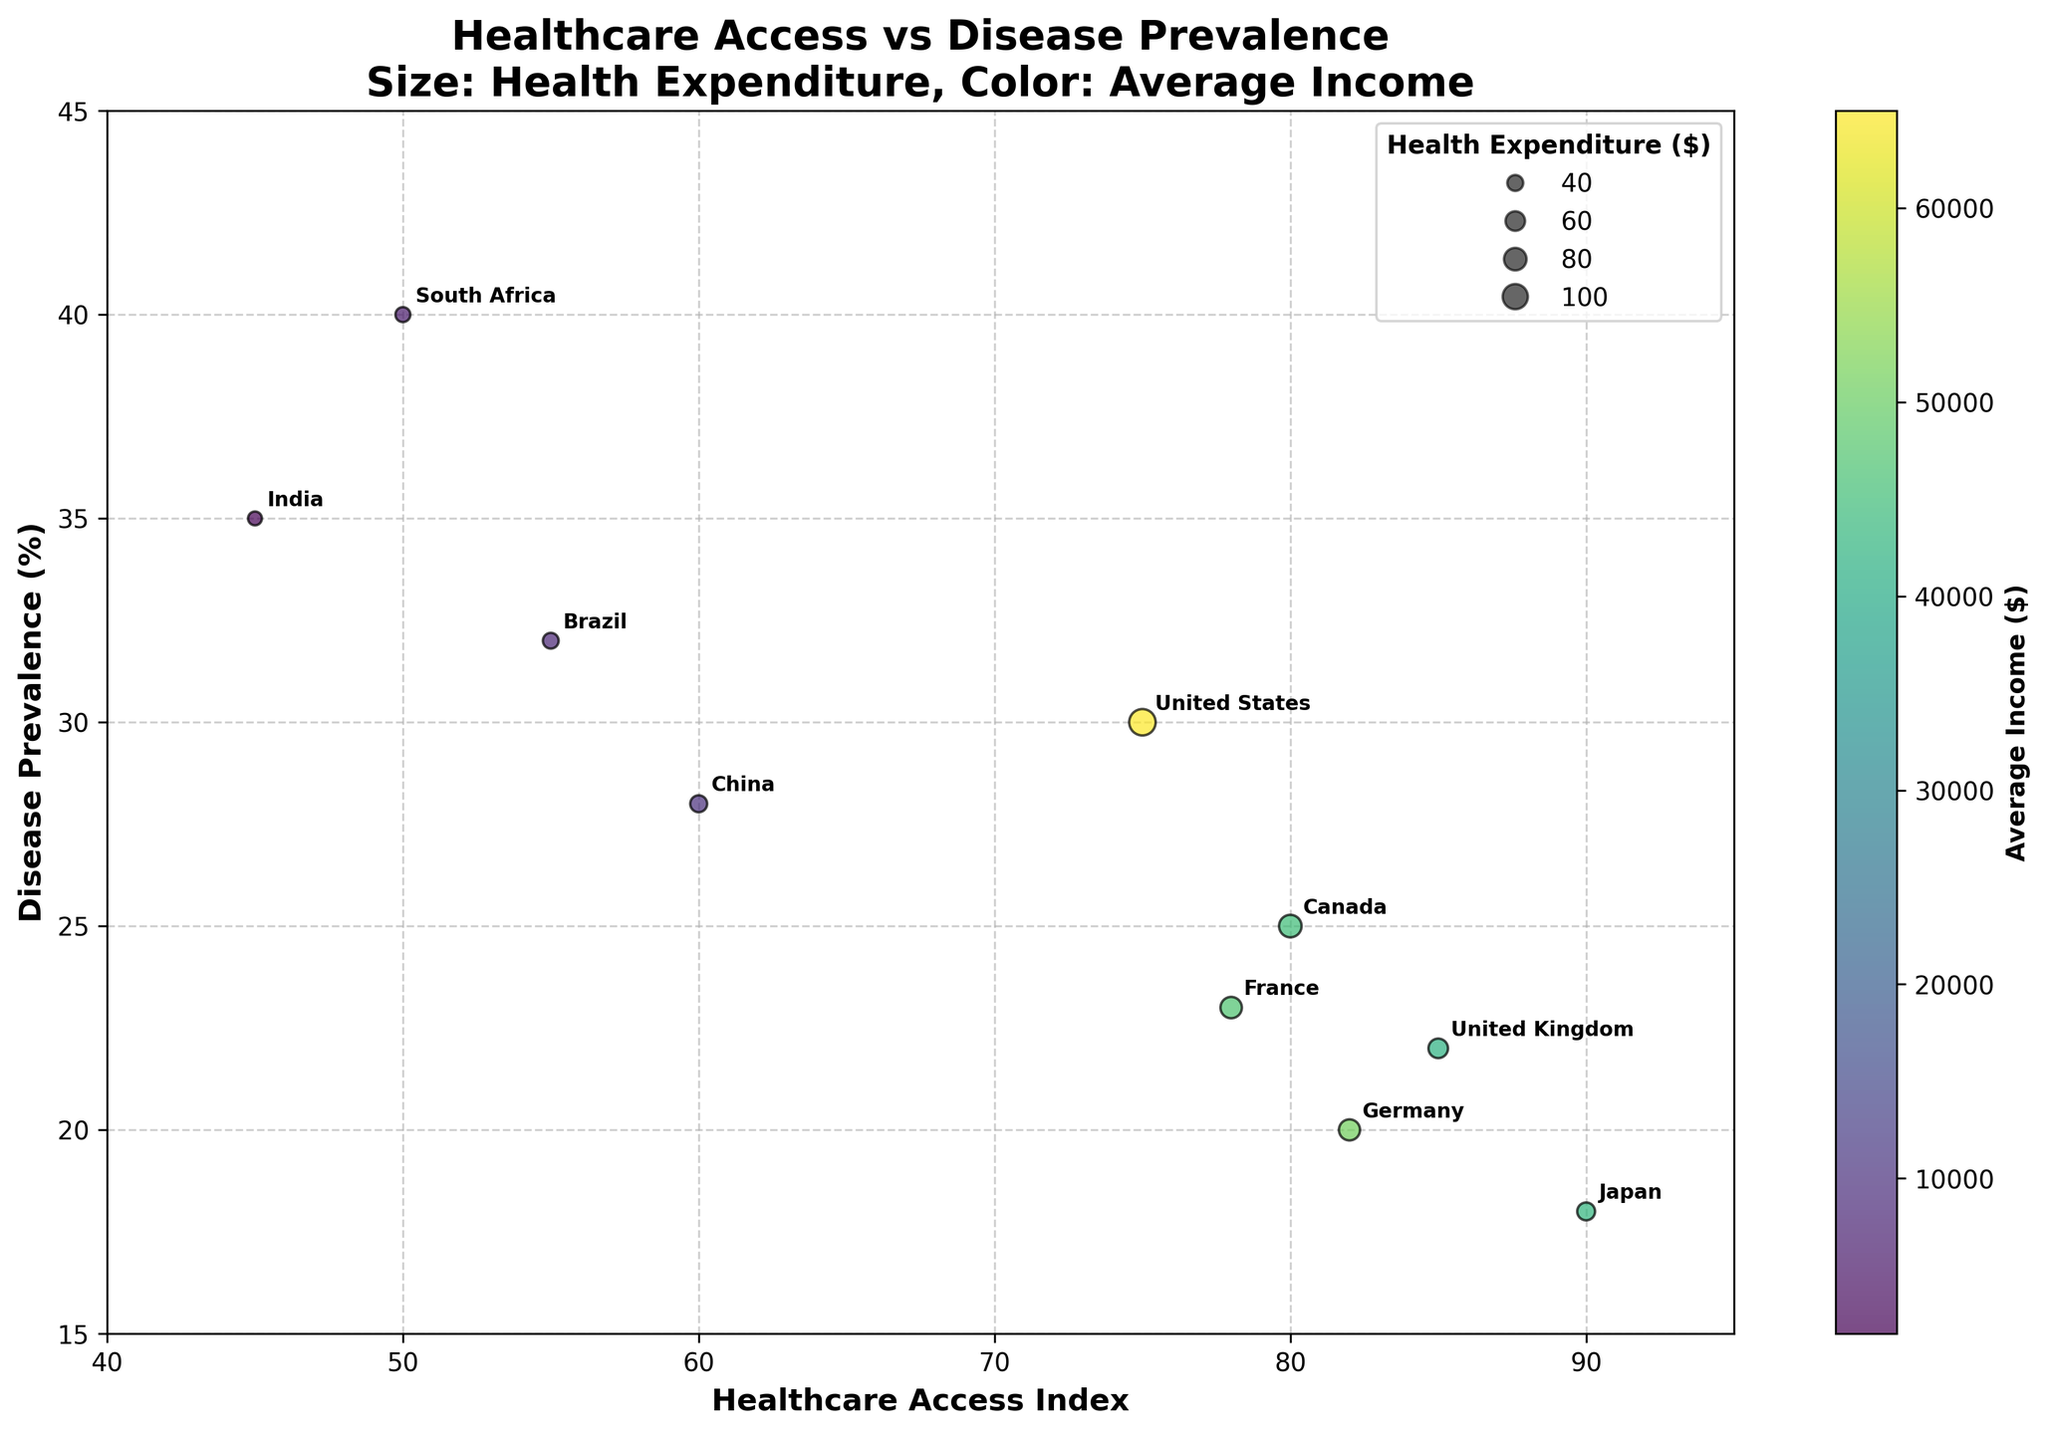what is the title of the figure? The title of the figure is displayed prominently at the top of the image, summarizing the visual content.
Answer: Healthcare Access vs Disease Prevalence How many countries are highlighted in the plot? By counting the annotated labels for each country in the scatter plot, we can see that there are 10 countries mentioned.
Answer: 10 Which country has the highest Disease Prevalence? From examining the scatter plot, South Africa is positioned the highest on the y-axis, indicating it has the highest Disease Prevalence.
Answer: South Africa Which country has the lowest Average Income? Looking at the color gradient of the bubbles, darker colors represent lower incomes. The darkest bubble is annotated with "India".
Answer: India What is the Health Expenditure of the United States? By observing the size of the bubbles, we can see that the United States has the largest bubble, corresponding to the highest Health Expenditure in the plot.
Answer: 11000 What is the Healthcare Access Index for Canada and how does it compare to Germany? By locating Canada and Germany on the x-axis, we see that Canada has a Healthcare Access Index of 80, which is less than Germany's index of 82.
Answer: Canada: 80, Germany: 82 How does the Disease Prevalence of China compare to that of France? China's bubble is positioned higher on the y-axis with a Disease Prevalence of 28%, whereas France has a Disease Prevalence of 23%.
Answer: China: 28%, France: 23% What’s the average amount of Health Expenditure across all the countries? Summing the Health Expenditure values and dividing by the number of countries, (11000+8000+6000+7000+7200+5000+3000+4500+3900+3500)/10, we calculate the average.
Answer: 5920 Which countries have a Healthcare Access Index greater than 80? By observing the x-axis, the countries with a Healthcare Access Index above 80 are Canada (80), Germany (82), United Kingdom (85), and Japan (90).
Answer: Canada, Germany, United Kingdom, Japan What is the relationship between Health Expenditure and Disease Prevalence? By analyzing the plot overall, it appears that countries with higher Health Expenditure tend to have lower Disease Prevalence, indicating an inverse relationship.
Answer: Inverse relationship 